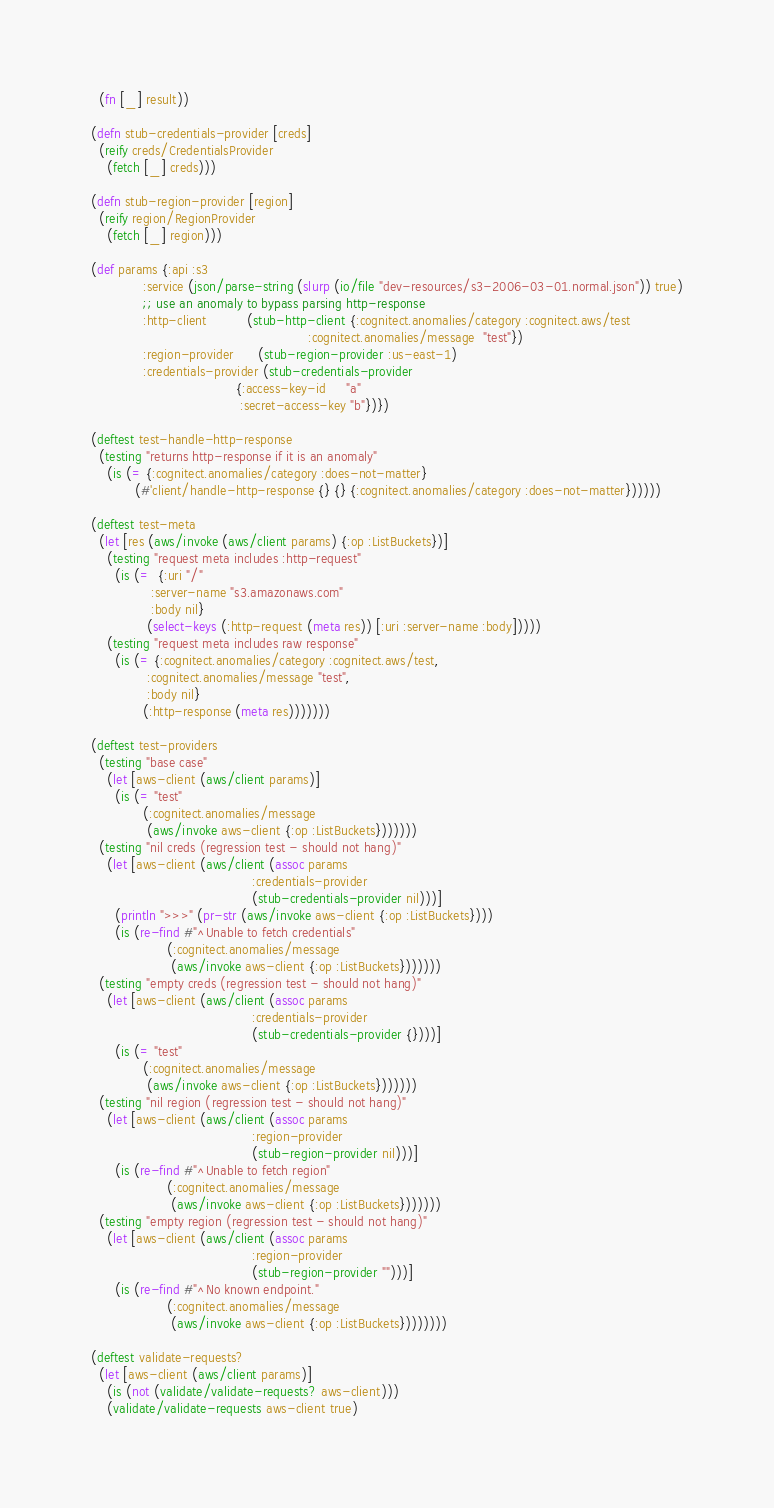<code> <loc_0><loc_0><loc_500><loc_500><_Clojure_>  (fn [_] result))

(defn stub-credentials-provider [creds]
  (reify creds/CredentialsProvider
    (fetch [_] creds)))

(defn stub-region-provider [region]
  (reify region/RegionProvider
    (fetch [_] region)))

(def params {:api :s3
             :service (json/parse-string (slurp (io/file "dev-resources/s3-2006-03-01.normal.json")) true)
             ;; use an anomaly to bypass parsing http-response
             :http-client          (stub-http-client {:cognitect.anomalies/category :cognitect.aws/test
                                                      :cognitect.anomalies/message  "test"})
             :region-provider      (stub-region-provider :us-east-1)
             :credentials-provider (stub-credentials-provider
                                    {:access-key-id     "a"
                                     :secret-access-key "b"})})

(deftest test-handle-http-response
  (testing "returns http-response if it is an anomaly"
    (is (= {:cognitect.anomalies/category :does-not-matter}
           (#'client/handle-http-response {} {} {:cognitect.anomalies/category :does-not-matter})))))

(deftest test-meta
  (let [res (aws/invoke (aws/client params) {:op :ListBuckets})]
    (testing "request meta includes :http-request"
      (is (=  {:uri "/"
               :server-name "s3.amazonaws.com"
               :body nil}
              (select-keys (:http-request (meta res)) [:uri :server-name :body]))))
    (testing "request meta includes raw response"
      (is (= {:cognitect.anomalies/category :cognitect.aws/test,
              :cognitect.anomalies/message "test",
              :body nil}
             (:http-response (meta res)))))))

(deftest test-providers
  (testing "base case"
    (let [aws-client (aws/client params)]
      (is (= "test"
             (:cognitect.anomalies/message
              (aws/invoke aws-client {:op :ListBuckets}))))))
  (testing "nil creds (regression test - should not hang)"
    (let [aws-client (aws/client (assoc params
                                        :credentials-provider
                                        (stub-credentials-provider nil)))]
      (println ">>>" (pr-str (aws/invoke aws-client {:op :ListBuckets})))
      (is (re-find #"^Unable to fetch credentials"
                   (:cognitect.anomalies/message
                    (aws/invoke aws-client {:op :ListBuckets}))))))
  (testing "empty creds (regression test - should not hang)"
    (let [aws-client (aws/client (assoc params
                                        :credentials-provider
                                        (stub-credentials-provider {})))]
      (is (= "test"
             (:cognitect.anomalies/message
              (aws/invoke aws-client {:op :ListBuckets}))))))
  (testing "nil region (regression test - should not hang)"
    (let [aws-client (aws/client (assoc params
                                        :region-provider
                                        (stub-region-provider nil)))]
      (is (re-find #"^Unable to fetch region"
                   (:cognitect.anomalies/message
                    (aws/invoke aws-client {:op :ListBuckets}))))))
  (testing "empty region (regression test - should not hang)"
    (let [aws-client (aws/client (assoc params
                                        :region-provider
                                        (stub-region-provider "")))]
      (is (re-find #"^No known endpoint."
                   (:cognitect.anomalies/message
                    (aws/invoke aws-client {:op :ListBuckets})))))))

(deftest validate-requests?
  (let [aws-client (aws/client params)]
    (is (not (validate/validate-requests? aws-client)))
    (validate/validate-requests aws-client true)</code> 